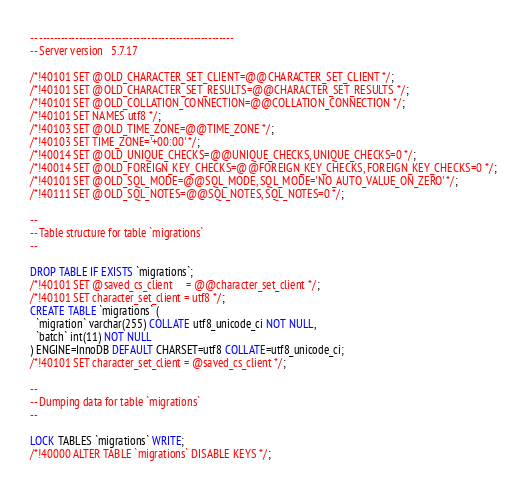Convert code to text. <code><loc_0><loc_0><loc_500><loc_500><_SQL_>-- ------------------------------------------------------
-- Server version	5.7.17

/*!40101 SET @OLD_CHARACTER_SET_CLIENT=@@CHARACTER_SET_CLIENT */;
/*!40101 SET @OLD_CHARACTER_SET_RESULTS=@@CHARACTER_SET_RESULTS */;
/*!40101 SET @OLD_COLLATION_CONNECTION=@@COLLATION_CONNECTION */;
/*!40101 SET NAMES utf8 */;
/*!40103 SET @OLD_TIME_ZONE=@@TIME_ZONE */;
/*!40103 SET TIME_ZONE='+00:00' */;
/*!40014 SET @OLD_UNIQUE_CHECKS=@@UNIQUE_CHECKS, UNIQUE_CHECKS=0 */;
/*!40014 SET @OLD_FOREIGN_KEY_CHECKS=@@FOREIGN_KEY_CHECKS, FOREIGN_KEY_CHECKS=0 */;
/*!40101 SET @OLD_SQL_MODE=@@SQL_MODE, SQL_MODE='NO_AUTO_VALUE_ON_ZERO' */;
/*!40111 SET @OLD_SQL_NOTES=@@SQL_NOTES, SQL_NOTES=0 */;

--
-- Table structure for table `migrations`
--

DROP TABLE IF EXISTS `migrations`;
/*!40101 SET @saved_cs_client     = @@character_set_client */;
/*!40101 SET character_set_client = utf8 */;
CREATE TABLE `migrations` (
  `migration` varchar(255) COLLATE utf8_unicode_ci NOT NULL,
  `batch` int(11) NOT NULL
) ENGINE=InnoDB DEFAULT CHARSET=utf8 COLLATE=utf8_unicode_ci;
/*!40101 SET character_set_client = @saved_cs_client */;

--
-- Dumping data for table `migrations`
--

LOCK TABLES `migrations` WRITE;
/*!40000 ALTER TABLE `migrations` DISABLE KEYS */;</code> 